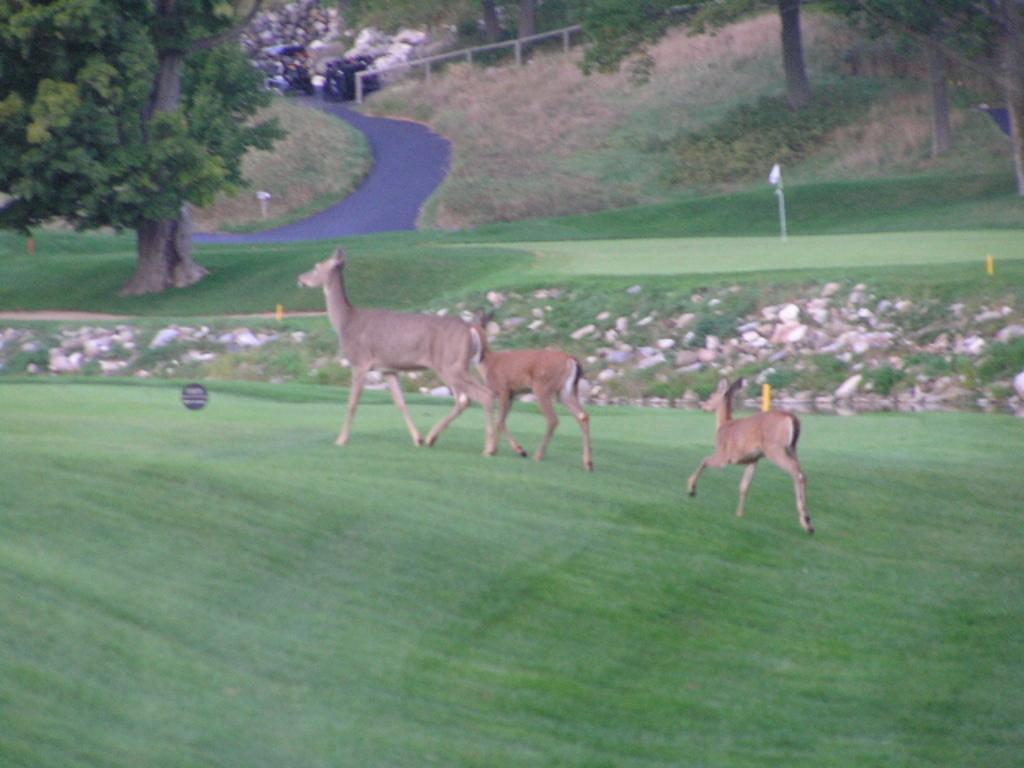What is located in the center of the image? There are animals in the center of the image. What type of terrain is depicted in the image? There is grass on the ground in the image. What other natural elements can be seen in the image? There are trees in the image. How would you describe the style of the image? The image is edited and graphical. What type of can is visible in the image? There is no can present in the image. What emotion is the image expressing, such as shame or happiness? The image does not express any specific emotion, as it is a depiction of animals, grass, and trees. 